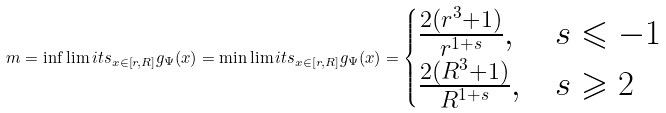Convert formula to latex. <formula><loc_0><loc_0><loc_500><loc_500>m = \inf \lim i t s _ { x \in [ r , R ] } g _ { \Psi } ( x ) = \min \lim i t s _ { x \in [ r , R ] } g _ { \Psi } ( x ) = \begin{cases} { \frac { 2 ( r ^ { 3 } + 1 ) } { r ^ { 1 + s } } , } & { s \leqslant - 1 } \\ { \frac { 2 ( R ^ { 3 } + 1 ) } { R ^ { 1 + s } } , } & { s \geqslant 2 } \\ \end{cases}</formula> 